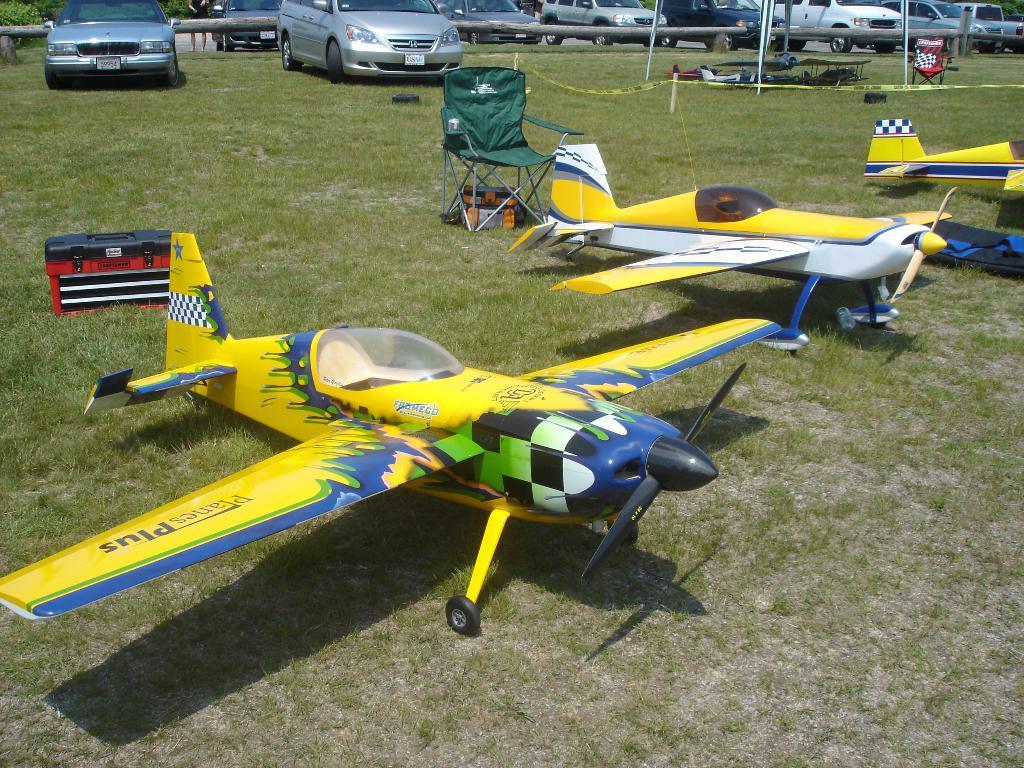How would you summarize this image in a sentence or two? In this picture we can see few chairs, a box and replica airplanes on the grass, in the background we can find few cars. 